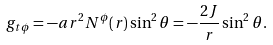<formula> <loc_0><loc_0><loc_500><loc_500>g _ { t \phi } = - a r ^ { 2 } N ^ { \phi } ( r ) \sin ^ { 2 } \theta = - \frac { 2 J } { r } \sin ^ { 2 } \theta .</formula> 